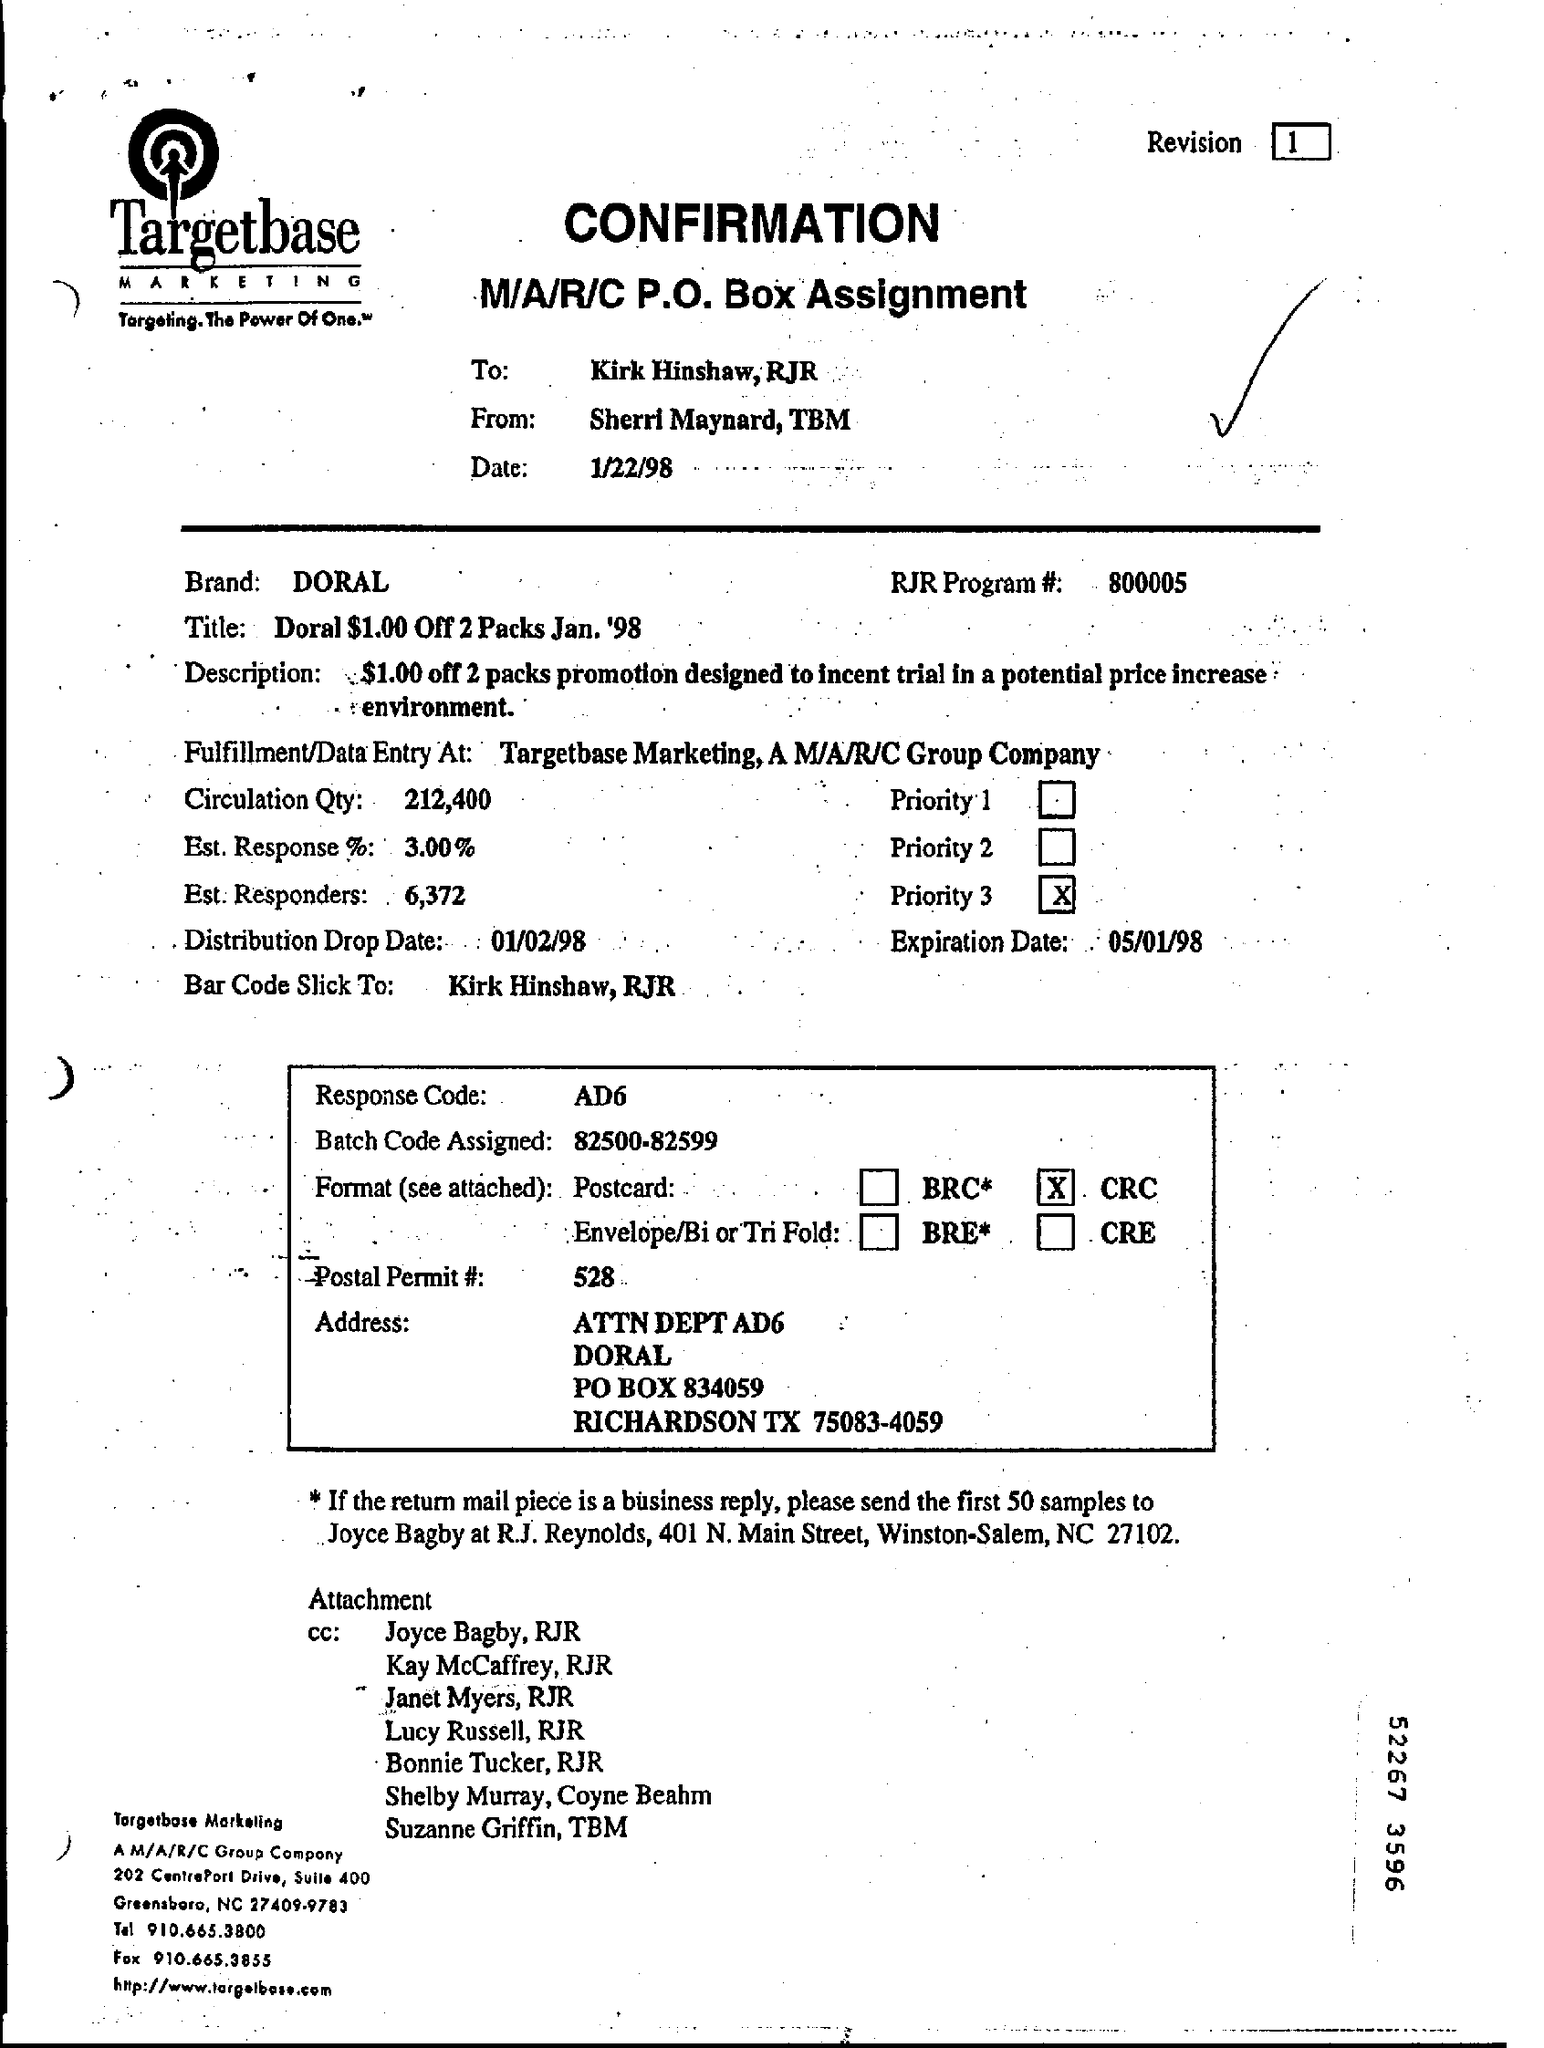What is the Revision No given in this document?
Make the answer very short. 1. Which brand is being mentioned in this document?
Give a very brief answer. DORAL. What is the RJR Program #(no) given in the document?
Provide a succinct answer. 800005. Who is the sender of this Confirmation document?
Offer a very short reply. Sherri Maynard, TBM. Who is the receiver of this Confirmation document?
Provide a short and direct response. Kirk Hinshaw, RJR. What is the response code mentioned in this document?
Give a very brief answer. AD6. What is the Batch Code Assigned as per the document?
Your answer should be very brief. 82500-82599. What is the Circulation Qty as per the document?
Your answer should be very brief. 212,400. What is the Distribution Drop Date mentioned in the document?
Offer a very short reply. 01/02/98. 